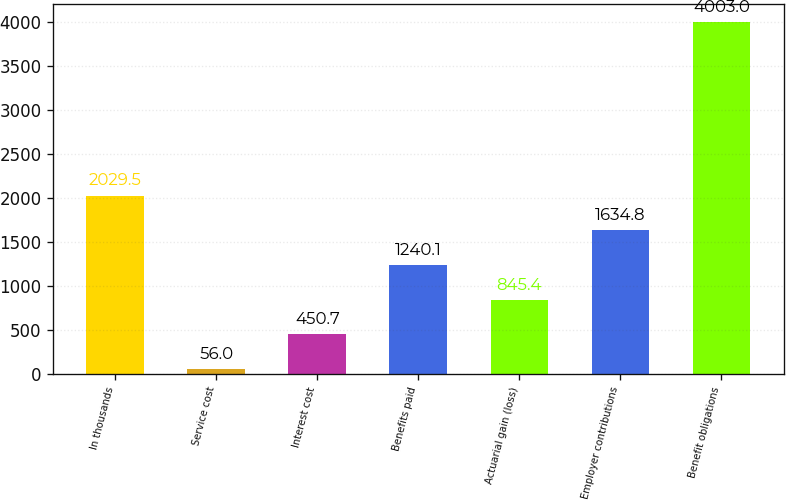Convert chart. <chart><loc_0><loc_0><loc_500><loc_500><bar_chart><fcel>In thousands<fcel>Service cost<fcel>Interest cost<fcel>Benefits paid<fcel>Actuarial gain (loss)<fcel>Employer contributions<fcel>Benefit obligations<nl><fcel>2029.5<fcel>56<fcel>450.7<fcel>1240.1<fcel>845.4<fcel>1634.8<fcel>4003<nl></chart> 